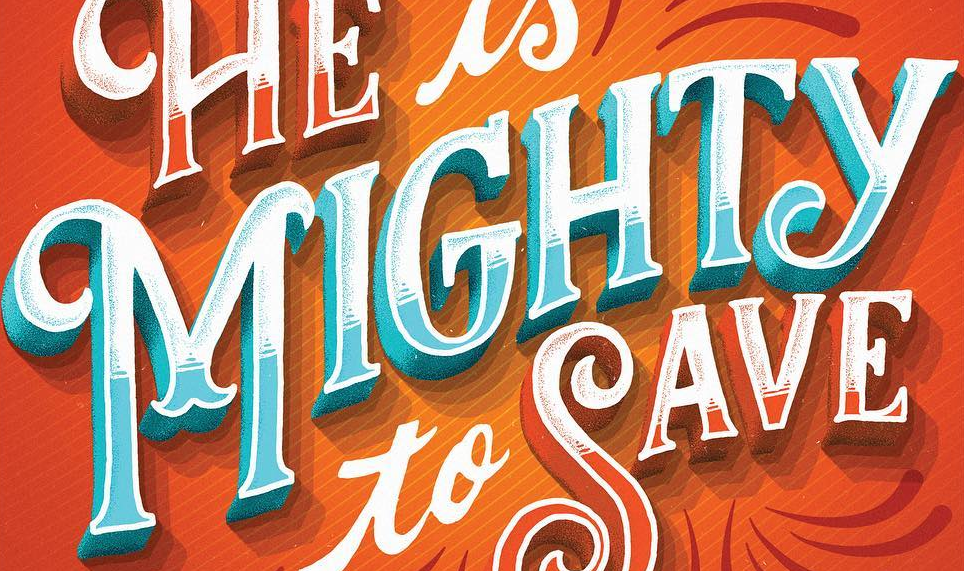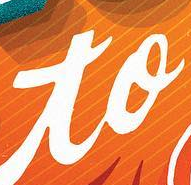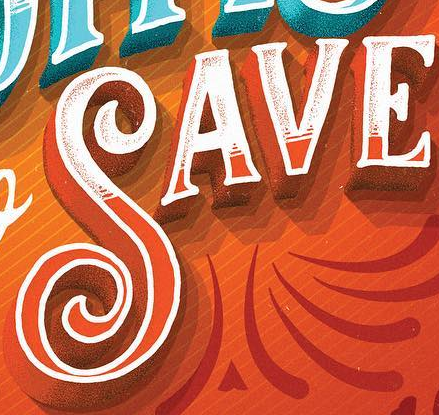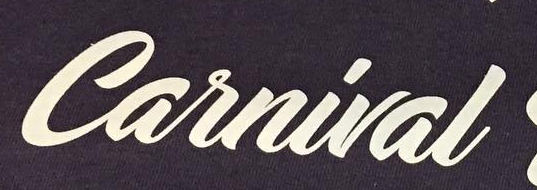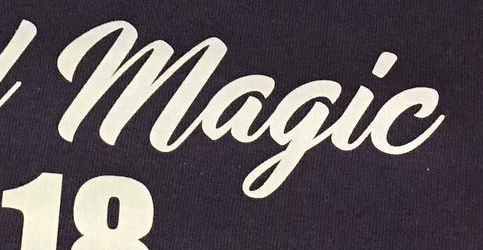What text is displayed in these images sequentially, separated by a semicolon? MIGHTY; to; SAVE; Carnival; Magic 